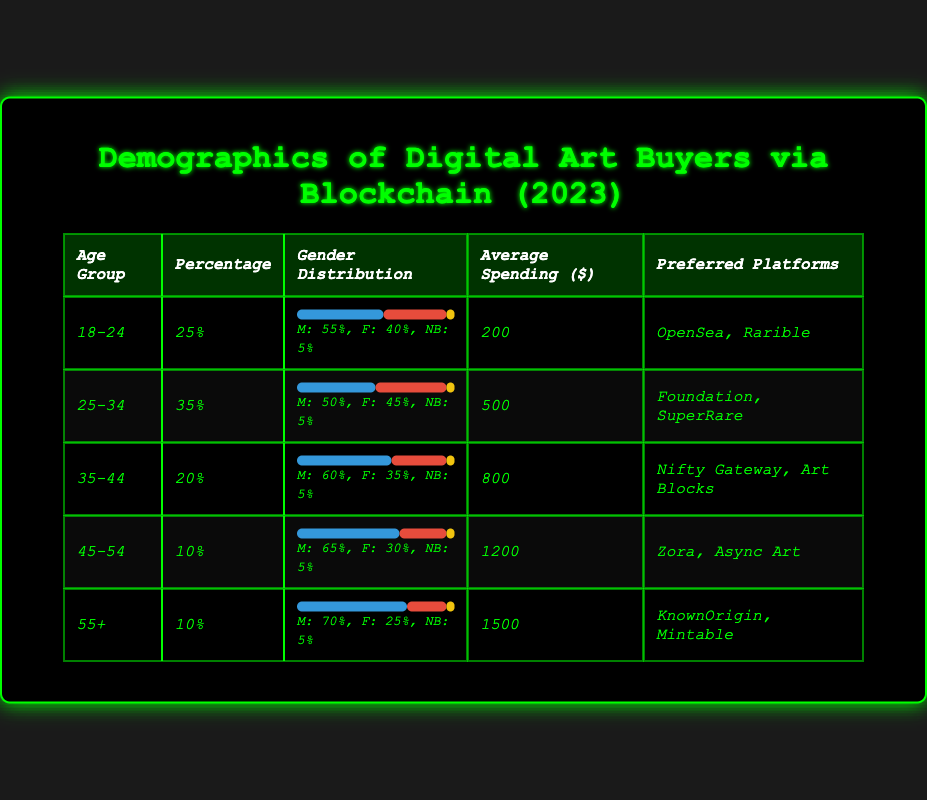What is the average spending of buyers aged 25-34? The average spending for this age group is listed in the table under the "Average Spending" column. For the age group 25-34, it is 500 dollars.
Answer: 500 Which age group has the highest percentage of digital art buyers? Referring to the "Percentage" column, the age group with the highest percentage is 25-34, which accounts for 35%.
Answer: 25-34 How many platforms are preferred by buyers aged 35-44? The table lists the preferred platforms for the 35-44 age group, which are Nifty Gateway and Art Blocks. Thus, there are two platforms.
Answer: 2 Are there more male or female buyers in the 18-24 age group? The gender distribution percentage shows that there are 55% male buyers and 40% female buyers in the 18-24 age group. Since 55 is greater than 40, there are more male buyers.
Answer: Male What is the gender distribution percentage for non-binary buyers in the 45-54 age group? For the 45-54 age group, the gender distribution shows that non-binary buyers represent 5% out of the total. This is directly stated in the distribution section for that age group.
Answer: 5% What is the total percentage of buyers aged 45 and older? To find this, sum the percentages of the 45-54 age group (10%) and the 55+ age group (10%): 10 + 10 = 20%. Therefore, the total percentage for buyers aged 45 and older is 20%.
Answer: 20% How does the average spending of the 55+ age group compare to the 18-24 age group? The average spending for the 55+ age group is 1500 dollars, while for the 18-24 age group it is 200 dollars. The difference is calculated as 1500 - 200 = 1300. Thus, the average spending of the 55+ age group is higher by 1300 dollars compared to the 18-24 age group.
Answer: Higher by 1300 What percentage of non-binary buyers is seen across all age groups? Across all age groups, the percentage of non-binary buyers is consistently listed as 5%. Since this is the same for each age group, it indicates that 5% of buyers in each group identify as non-binary.
Answer: 5% 